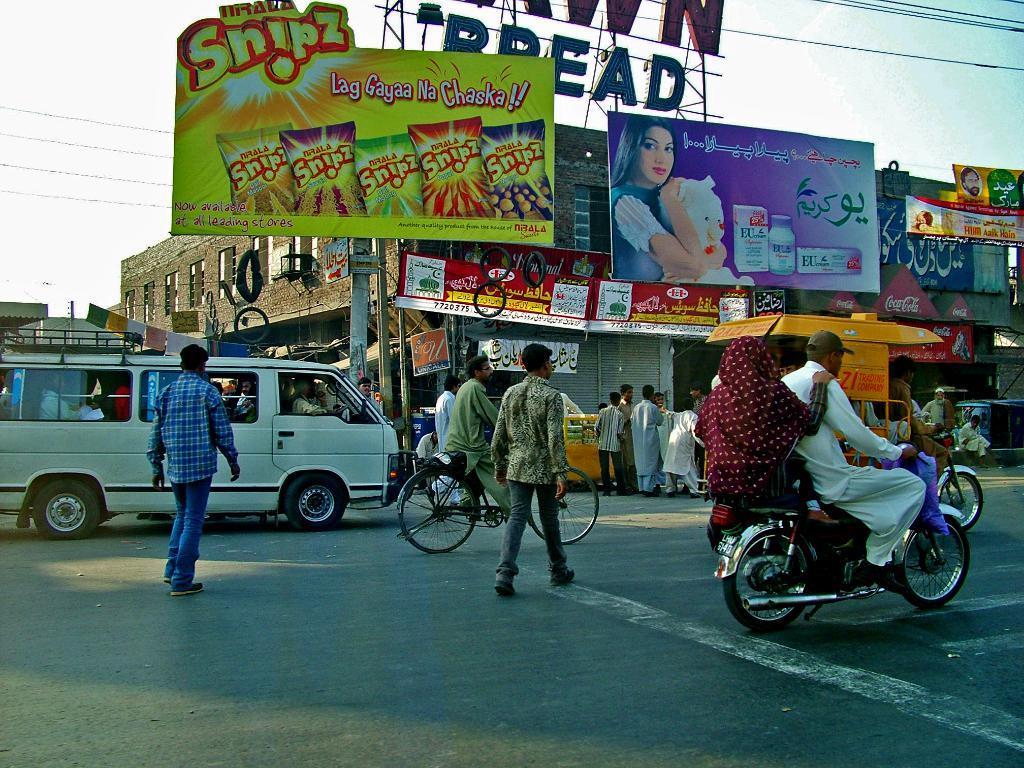Describe this image in one or two sentences. This image is clicked outside. There is a building in the middle and there are advertisements on that building. There is sky and wires on the top. In the middle there is a bicycle motorcycle and van. People are crossing road. 